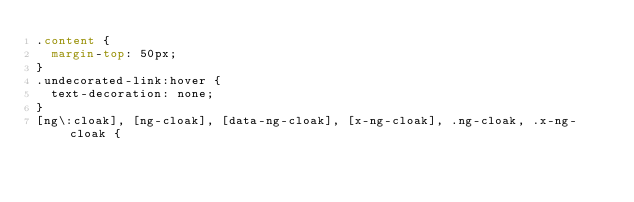<code> <loc_0><loc_0><loc_500><loc_500><_CSS_>.content {
  margin-top: 50px;
}
.undecorated-link:hover {
  text-decoration: none;
}
[ng\:cloak], [ng-cloak], [data-ng-cloak], [x-ng-cloak], .ng-cloak, .x-ng-cloak {</code> 